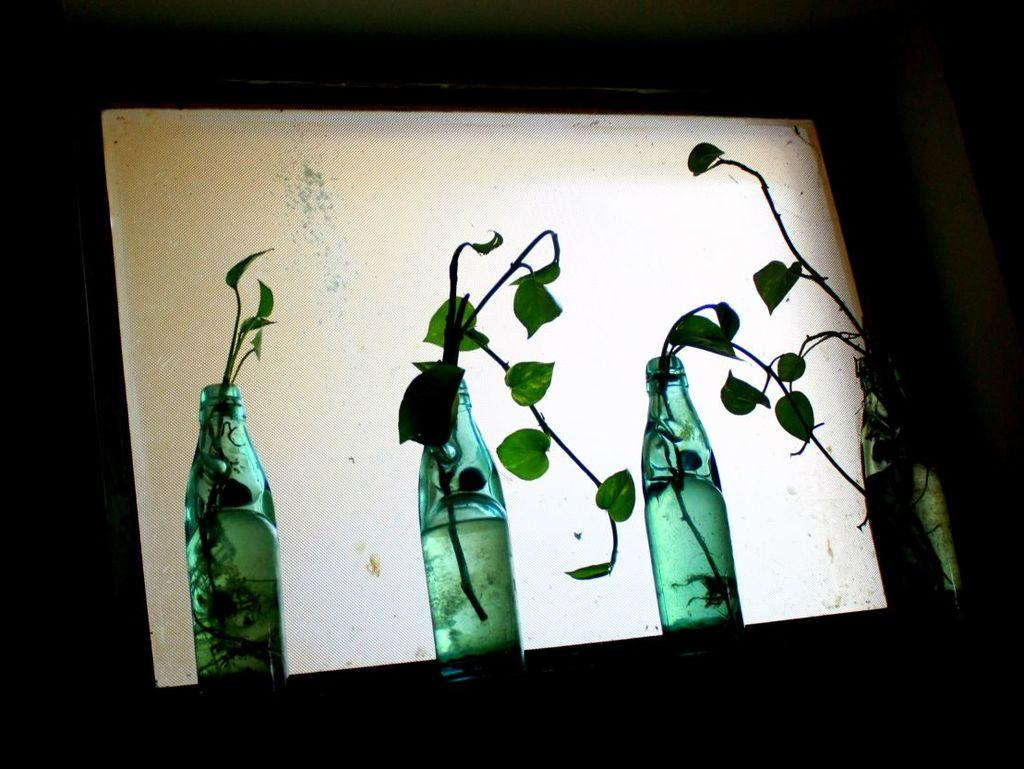What type of beverage containers are present in the image? There are soda bottles in the soda bottles in the image. What is unique about the contents of the soda bottles? The soda bottles contain plants. How many letters does your uncle send you every month from the image? There is no mention of letters or an uncle in the image, so this question cannot be answered. 